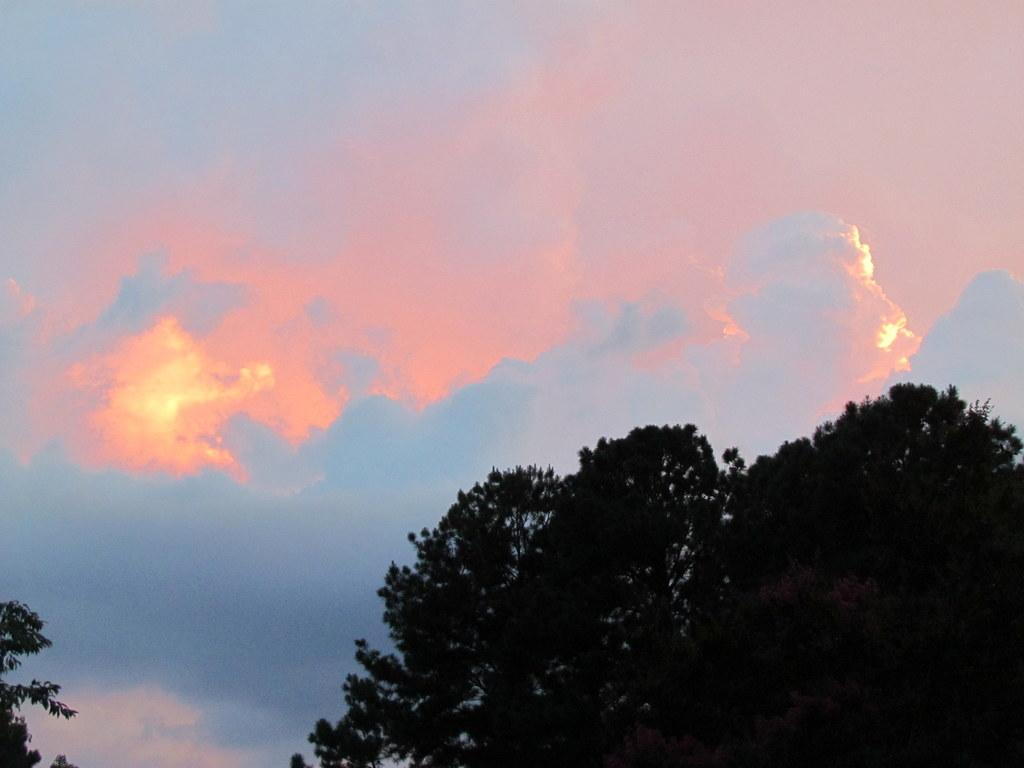What type of vegetation can be seen in the image? There are trees visible in the image. What can be seen in the sky in the image? There are clouds in the sky in the image. What type of skirt is being worn by the butter in the image? There is no butter or skirt present in the image. 